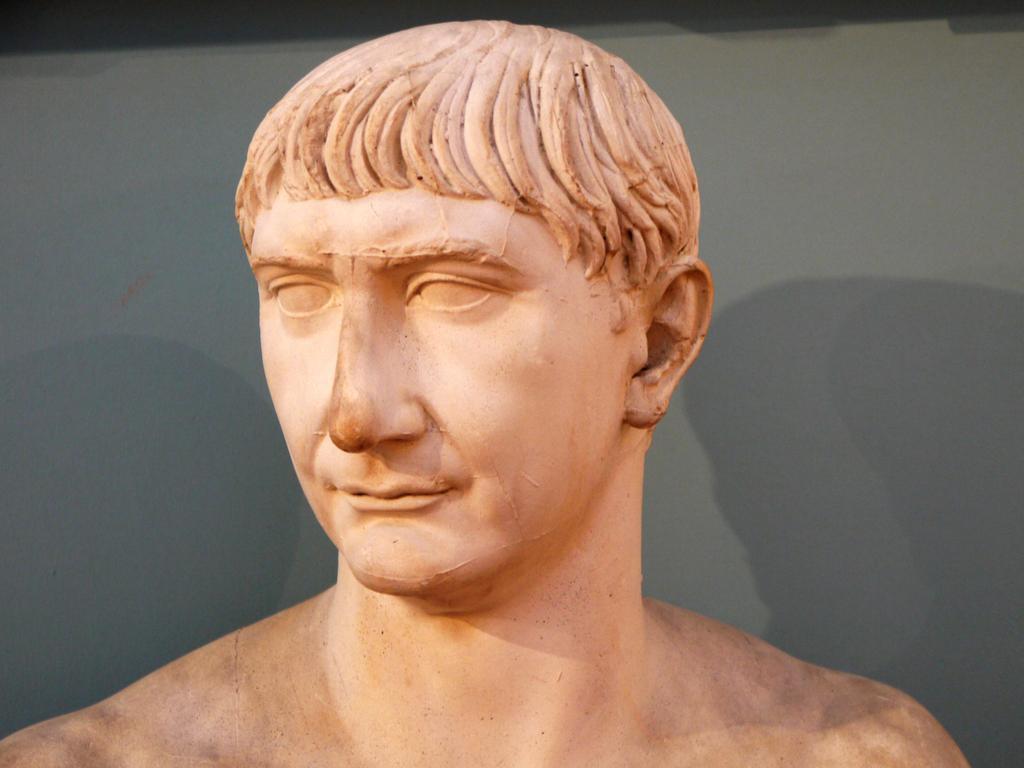In one or two sentences, can you explain what this image depicts? In the center of the image there is a statue. In the background we can see wall. 